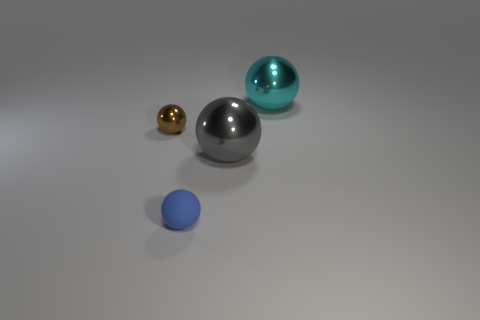Add 4 purple metallic balls. How many objects exist? 8 Subtract all tiny things. Subtract all large objects. How many objects are left? 0 Add 3 tiny brown metallic balls. How many tiny brown metallic balls are left? 4 Add 4 big cyan things. How many big cyan things exist? 5 Subtract 0 red cylinders. How many objects are left? 4 